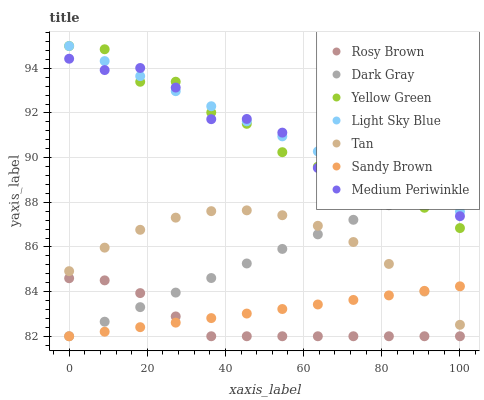Does Rosy Brown have the minimum area under the curve?
Answer yes or no. Yes. Does Light Sky Blue have the maximum area under the curve?
Answer yes or no. Yes. Does Medium Periwinkle have the minimum area under the curve?
Answer yes or no. No. Does Medium Periwinkle have the maximum area under the curve?
Answer yes or no. No. Is Light Sky Blue the smoothest?
Answer yes or no. Yes. Is Medium Periwinkle the roughest?
Answer yes or no. Yes. Is Rosy Brown the smoothest?
Answer yes or no. No. Is Rosy Brown the roughest?
Answer yes or no. No. Does Rosy Brown have the lowest value?
Answer yes or no. Yes. Does Medium Periwinkle have the lowest value?
Answer yes or no. No. Does Light Sky Blue have the highest value?
Answer yes or no. Yes. Does Rosy Brown have the highest value?
Answer yes or no. No. Is Tan less than Light Sky Blue?
Answer yes or no. Yes. Is Light Sky Blue greater than Tan?
Answer yes or no. Yes. Does Sandy Brown intersect Rosy Brown?
Answer yes or no. Yes. Is Sandy Brown less than Rosy Brown?
Answer yes or no. No. Is Sandy Brown greater than Rosy Brown?
Answer yes or no. No. Does Tan intersect Light Sky Blue?
Answer yes or no. No. 